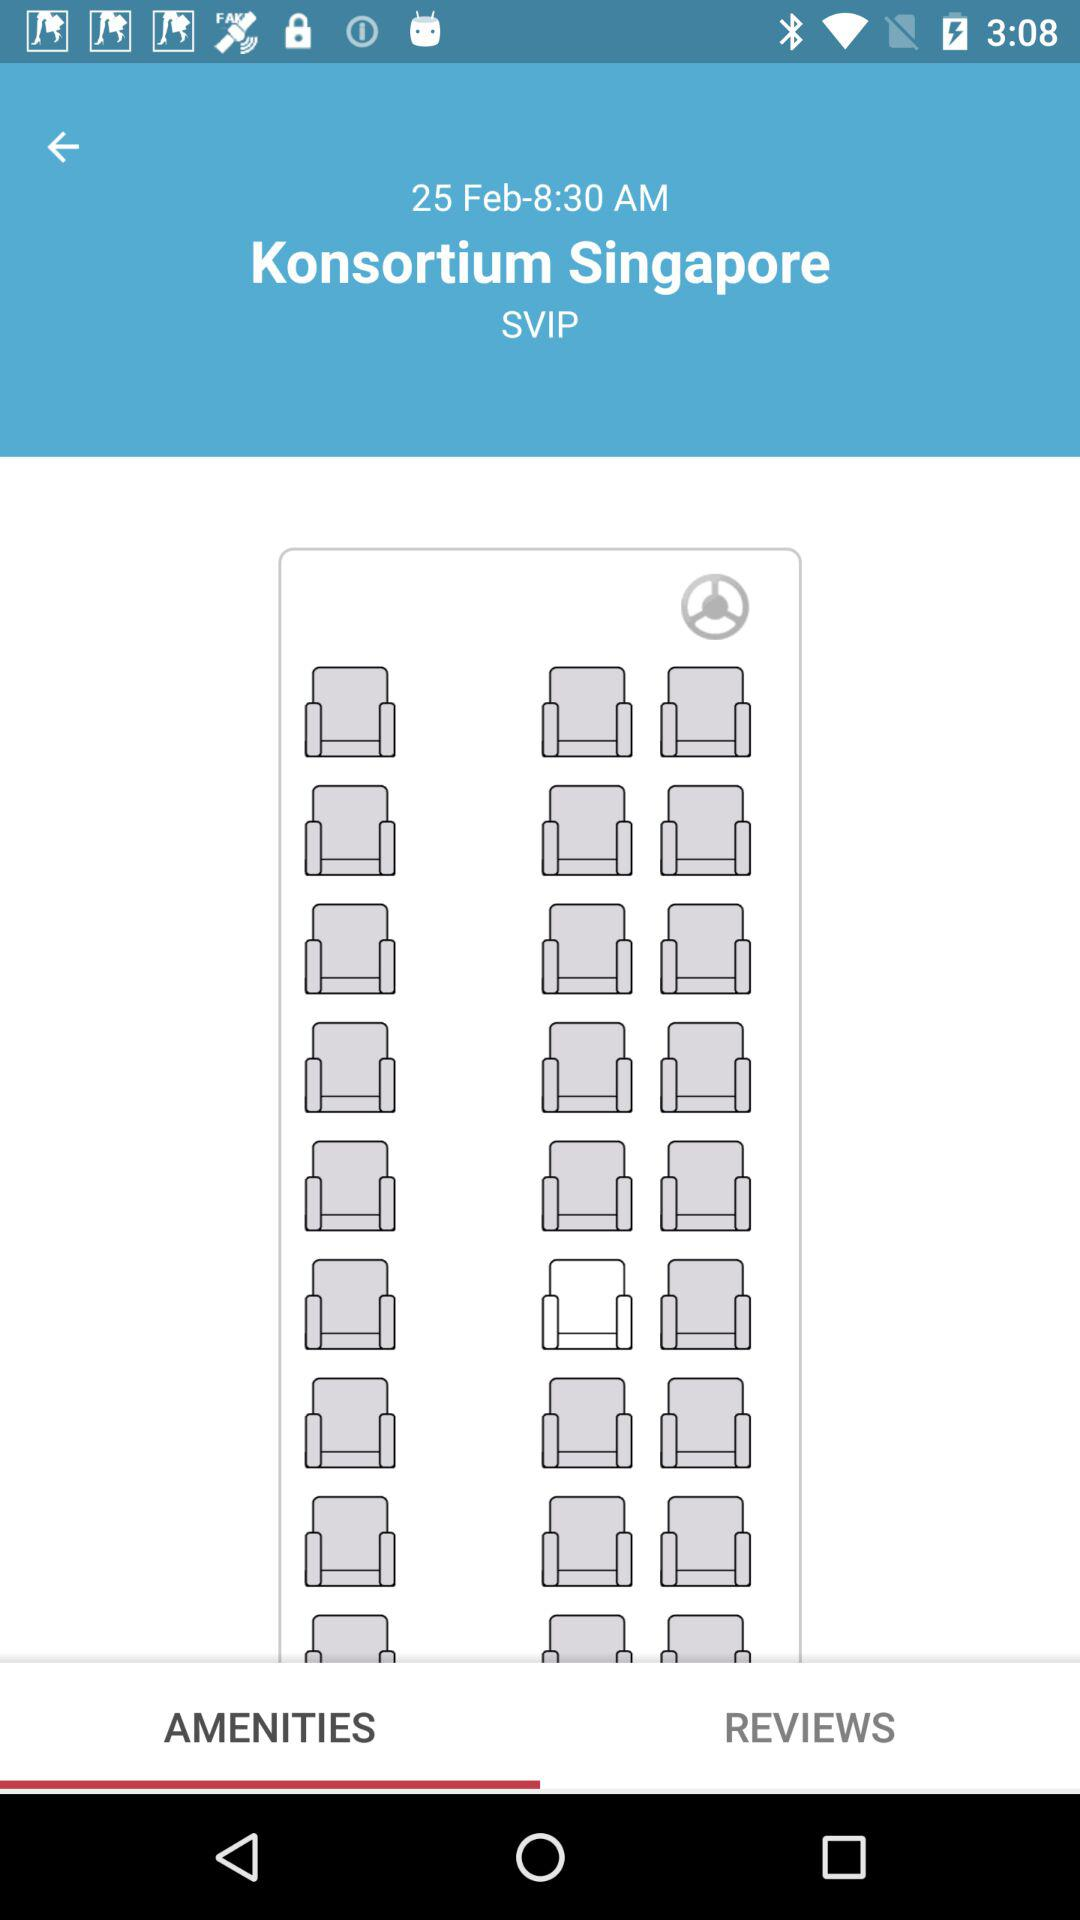What is the location?
When the provided information is insufficient, respond with <no answer>. <no answer> 